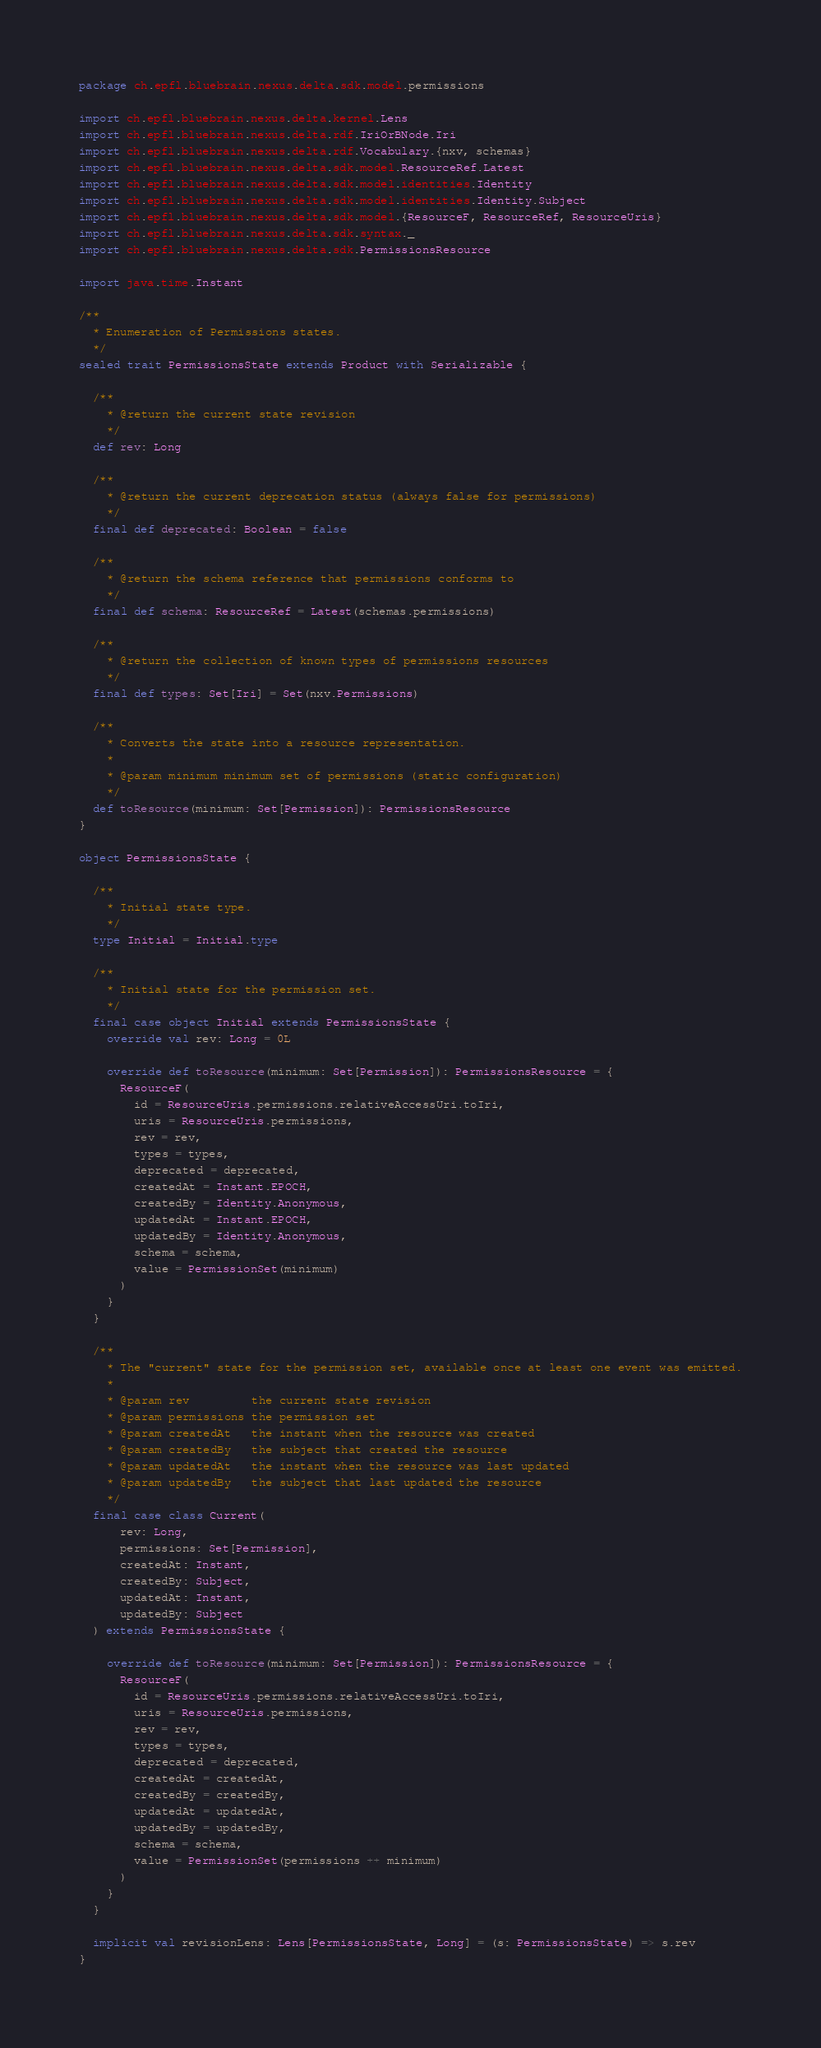<code> <loc_0><loc_0><loc_500><loc_500><_Scala_>package ch.epfl.bluebrain.nexus.delta.sdk.model.permissions

import ch.epfl.bluebrain.nexus.delta.kernel.Lens
import ch.epfl.bluebrain.nexus.delta.rdf.IriOrBNode.Iri
import ch.epfl.bluebrain.nexus.delta.rdf.Vocabulary.{nxv, schemas}
import ch.epfl.bluebrain.nexus.delta.sdk.model.ResourceRef.Latest
import ch.epfl.bluebrain.nexus.delta.sdk.model.identities.Identity
import ch.epfl.bluebrain.nexus.delta.sdk.model.identities.Identity.Subject
import ch.epfl.bluebrain.nexus.delta.sdk.model.{ResourceF, ResourceRef, ResourceUris}
import ch.epfl.bluebrain.nexus.delta.sdk.syntax._
import ch.epfl.bluebrain.nexus.delta.sdk.PermissionsResource

import java.time.Instant

/**
  * Enumeration of Permissions states.
  */
sealed trait PermissionsState extends Product with Serializable {

  /**
    * @return the current state revision
    */
  def rev: Long

  /**
    * @return the current deprecation status (always false for permissions)
    */
  final def deprecated: Boolean = false

  /**
    * @return the schema reference that permissions conforms to
    */
  final def schema: ResourceRef = Latest(schemas.permissions)

  /**
    * @return the collection of known types of permissions resources
    */
  final def types: Set[Iri] = Set(nxv.Permissions)

  /**
    * Converts the state into a resource representation.
    *
    * @param minimum minimum set of permissions (static configuration)
    */
  def toResource(minimum: Set[Permission]): PermissionsResource
}

object PermissionsState {

  /**
    * Initial state type.
    */
  type Initial = Initial.type

  /**
    * Initial state for the permission set.
    */
  final case object Initial extends PermissionsState {
    override val rev: Long = 0L

    override def toResource(minimum: Set[Permission]): PermissionsResource = {
      ResourceF(
        id = ResourceUris.permissions.relativeAccessUri.toIri,
        uris = ResourceUris.permissions,
        rev = rev,
        types = types,
        deprecated = deprecated,
        createdAt = Instant.EPOCH,
        createdBy = Identity.Anonymous,
        updatedAt = Instant.EPOCH,
        updatedBy = Identity.Anonymous,
        schema = schema,
        value = PermissionSet(minimum)
      )
    }
  }

  /**
    * The "current" state for the permission set, available once at least one event was emitted.
    *
    * @param rev         the current state revision
    * @param permissions the permission set
    * @param createdAt   the instant when the resource was created
    * @param createdBy   the subject that created the resource
    * @param updatedAt   the instant when the resource was last updated
    * @param updatedBy   the subject that last updated the resource
    */
  final case class Current(
      rev: Long,
      permissions: Set[Permission],
      createdAt: Instant,
      createdBy: Subject,
      updatedAt: Instant,
      updatedBy: Subject
  ) extends PermissionsState {

    override def toResource(minimum: Set[Permission]): PermissionsResource = {
      ResourceF(
        id = ResourceUris.permissions.relativeAccessUri.toIri,
        uris = ResourceUris.permissions,
        rev = rev,
        types = types,
        deprecated = deprecated,
        createdAt = createdAt,
        createdBy = createdBy,
        updatedAt = updatedAt,
        updatedBy = updatedBy,
        schema = schema,
        value = PermissionSet(permissions ++ minimum)
      )
    }
  }

  implicit val revisionLens: Lens[PermissionsState, Long] = (s: PermissionsState) => s.rev
}
</code> 